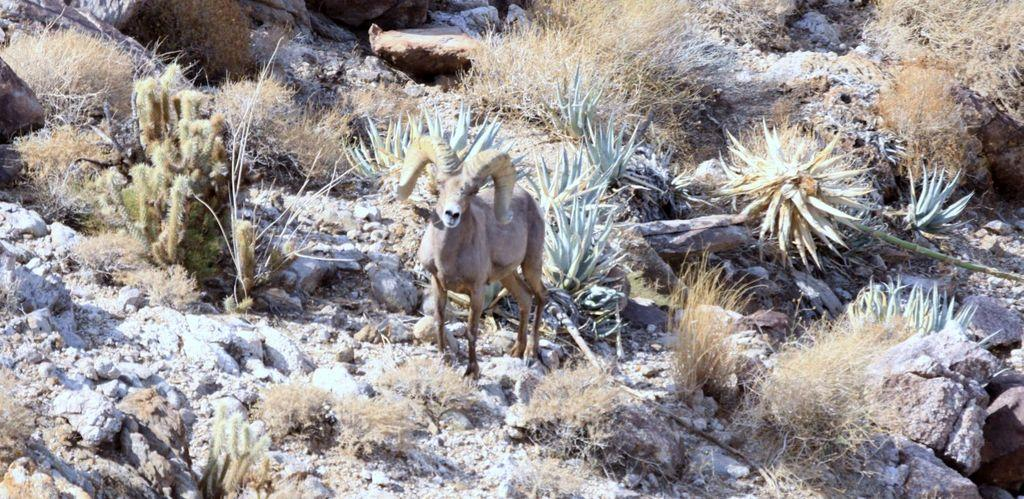What animal can be seen on the ground in the image? There is a ram on the ground in the image. What type of objects are present in the image? There are stones and plants in the image. Can you describe the plants in the image? There are plants and dried plants on the ground in the background of the image. What type of coat is the ram wearing in the image? Rams do not wear coats; they have natural fur or wool. 